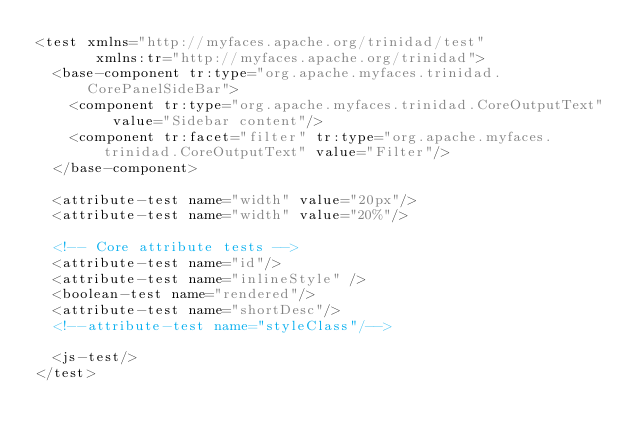Convert code to text. <code><loc_0><loc_0><loc_500><loc_500><_XML_><test xmlns="http://myfaces.apache.org/trinidad/test"
       xmlns:tr="http://myfaces.apache.org/trinidad">
  <base-component tr:type="org.apache.myfaces.trinidad.CorePanelSideBar">
    <component tr:type="org.apache.myfaces.trinidad.CoreOutputText" value="Sidebar content"/>
    <component tr:facet="filter" tr:type="org.apache.myfaces.trinidad.CoreOutputText" value="Filter"/>
  </base-component>
  
  <attribute-test name="width" value="20px"/>
  <attribute-test name="width" value="20%"/>
  
  <!-- Core attribute tests -->
  <attribute-test name="id"/>
  <attribute-test name="inlineStyle" />
  <boolean-test name="rendered"/>
  <attribute-test name="shortDesc"/>
  <!--attribute-test name="styleClass"/-->

  <js-test/>
</test>
</code> 